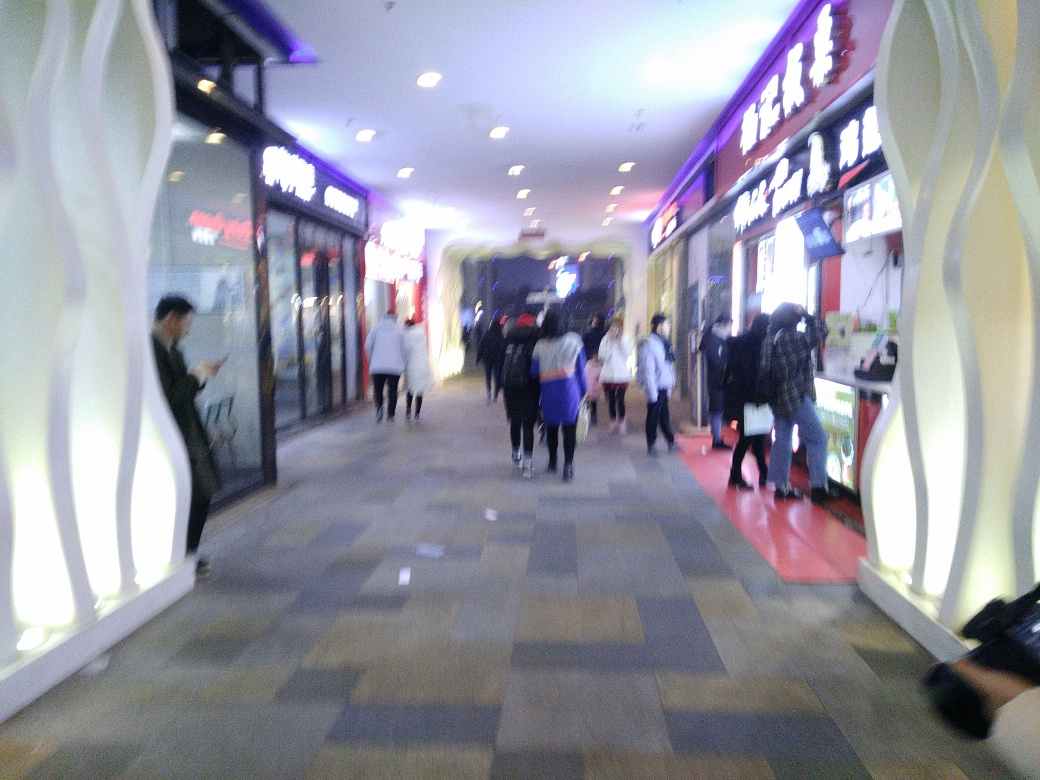Is there anything in the image that could help determine the time of day or occasion? The image quality impedes making a precise judgment, but the artificial lighting and the indoor environment provide no distinct clues about the time of day. Without clear visibility of windows or outdoor light, the occasion remains ambiguous. 